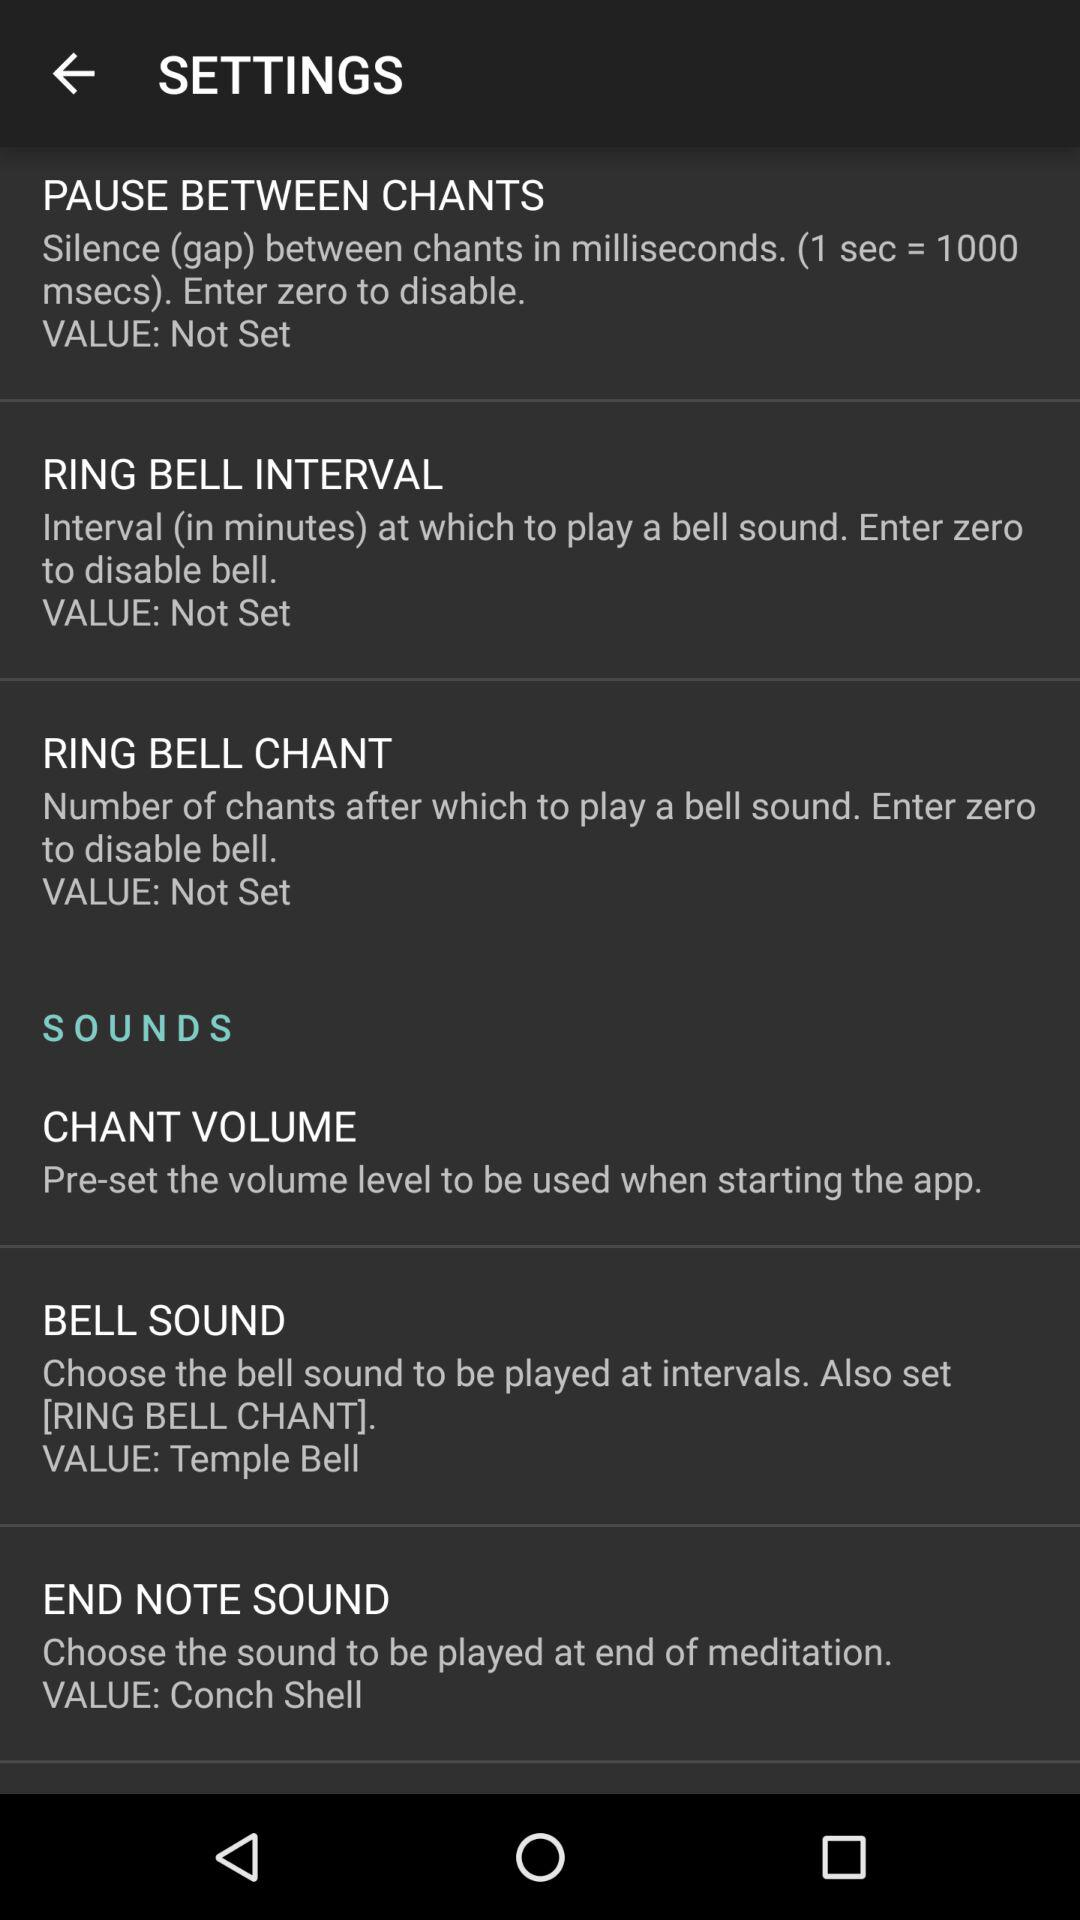What is the value set for "END NOTE SOUND"? The value set for "END NOTE SOUND" is "Conch Shell". 